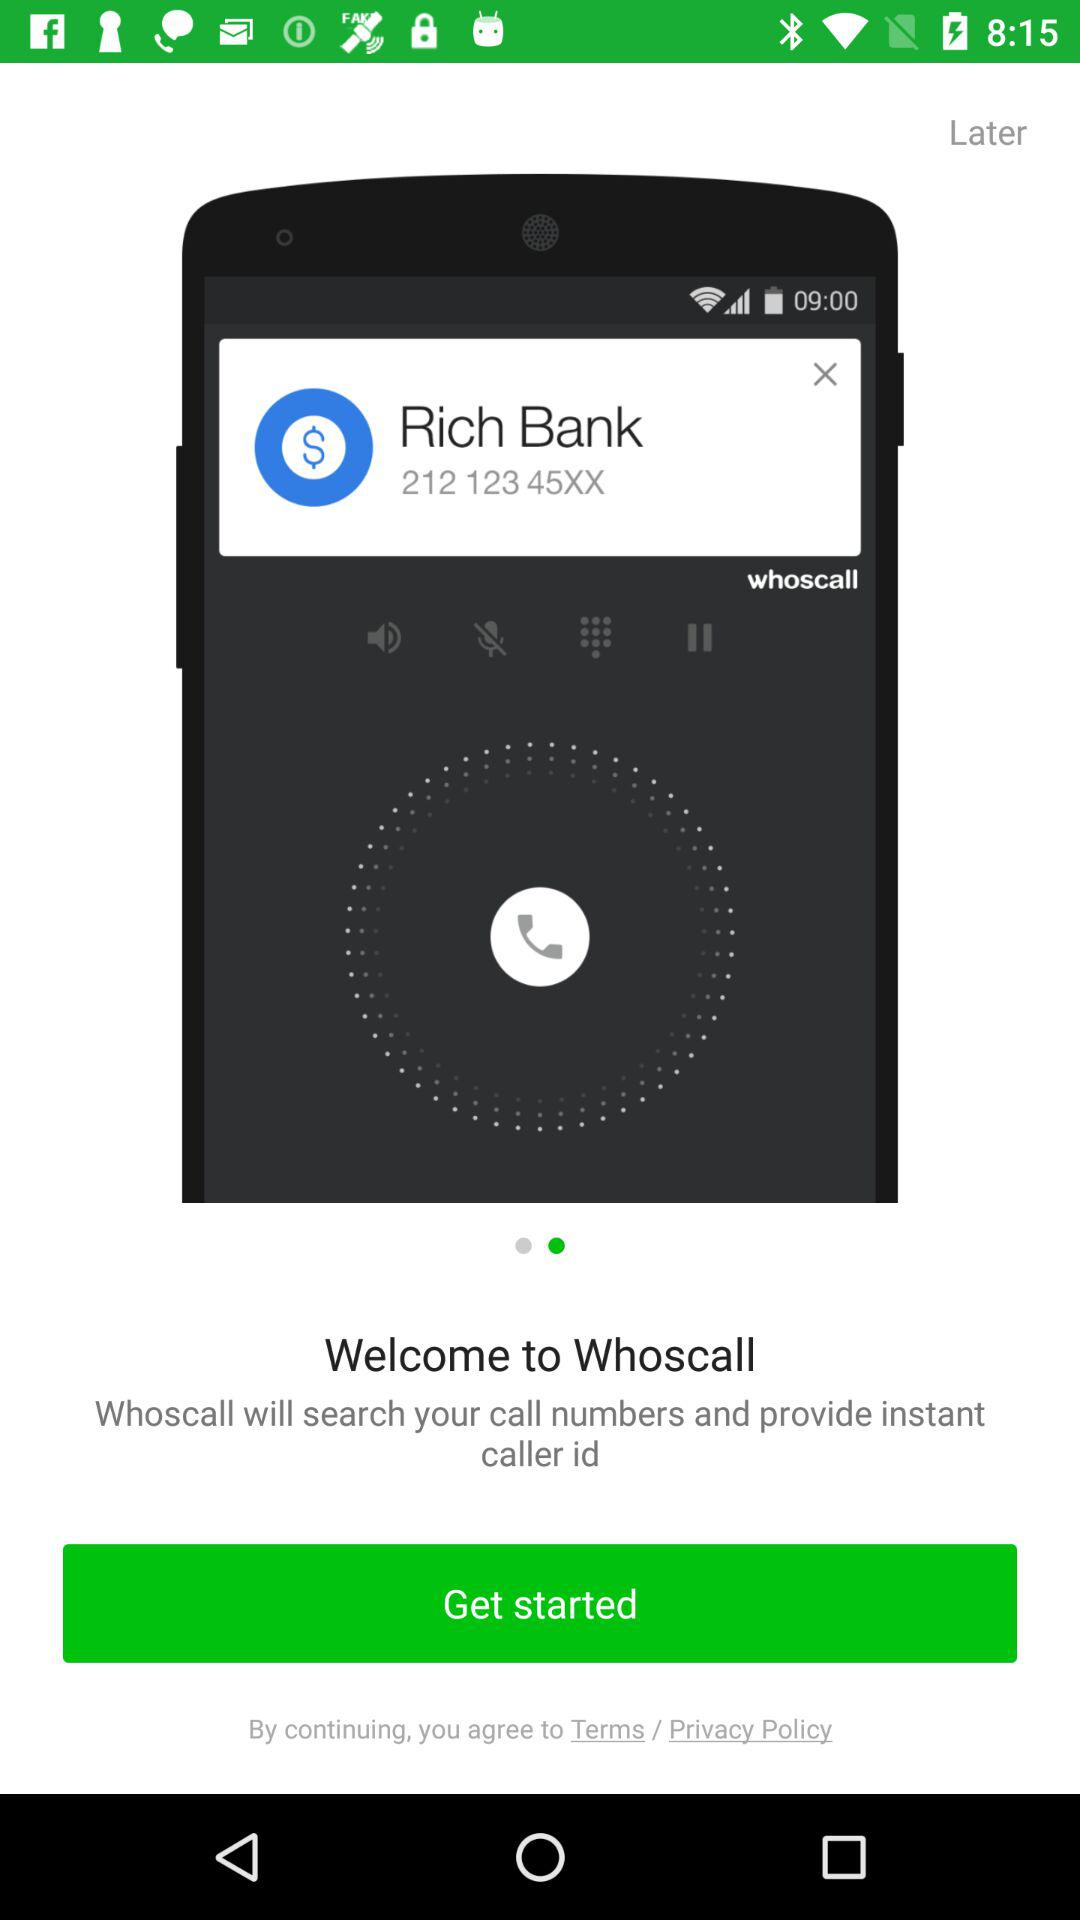What is the name of the application that will search the call numbers and provide instant caller ID? The name of the application is "Whoscall". 